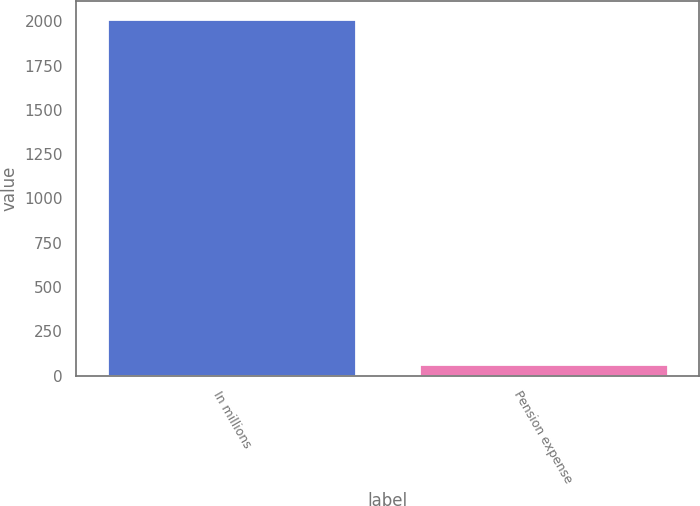Convert chart to OTSL. <chart><loc_0><loc_0><loc_500><loc_500><bar_chart><fcel>In millions<fcel>Pension expense<nl><fcel>2011<fcel>68<nl></chart> 